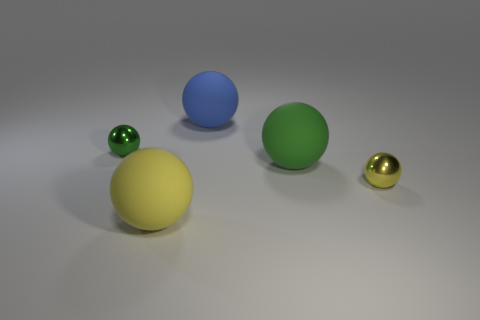There is a thing to the left of the yellow rubber thing; what is its shape?
Ensure brevity in your answer.  Sphere. What is the color of the metallic sphere that is behind the tiny ball to the right of the large yellow matte object?
Ensure brevity in your answer.  Green. What number of objects are big green matte balls that are on the left side of the small yellow shiny thing or yellow metallic objects?
Provide a succinct answer. 2. There is a yellow metallic ball; does it have the same size as the green metallic thing that is on the left side of the big green thing?
Your response must be concise. Yes. What number of tiny objects are either green cubes or rubber balls?
Provide a succinct answer. 0. Are there any big things that have the same material as the big green ball?
Give a very brief answer. Yes. Is the number of small yellow objects greater than the number of gray things?
Your answer should be compact. Yes. Is the blue ball made of the same material as the large green sphere?
Provide a short and direct response. Yes. How many metal objects are large yellow things or large blue spheres?
Provide a short and direct response. 0. There is a metallic thing that is the same size as the green shiny ball; what is its color?
Keep it short and to the point. Yellow. 